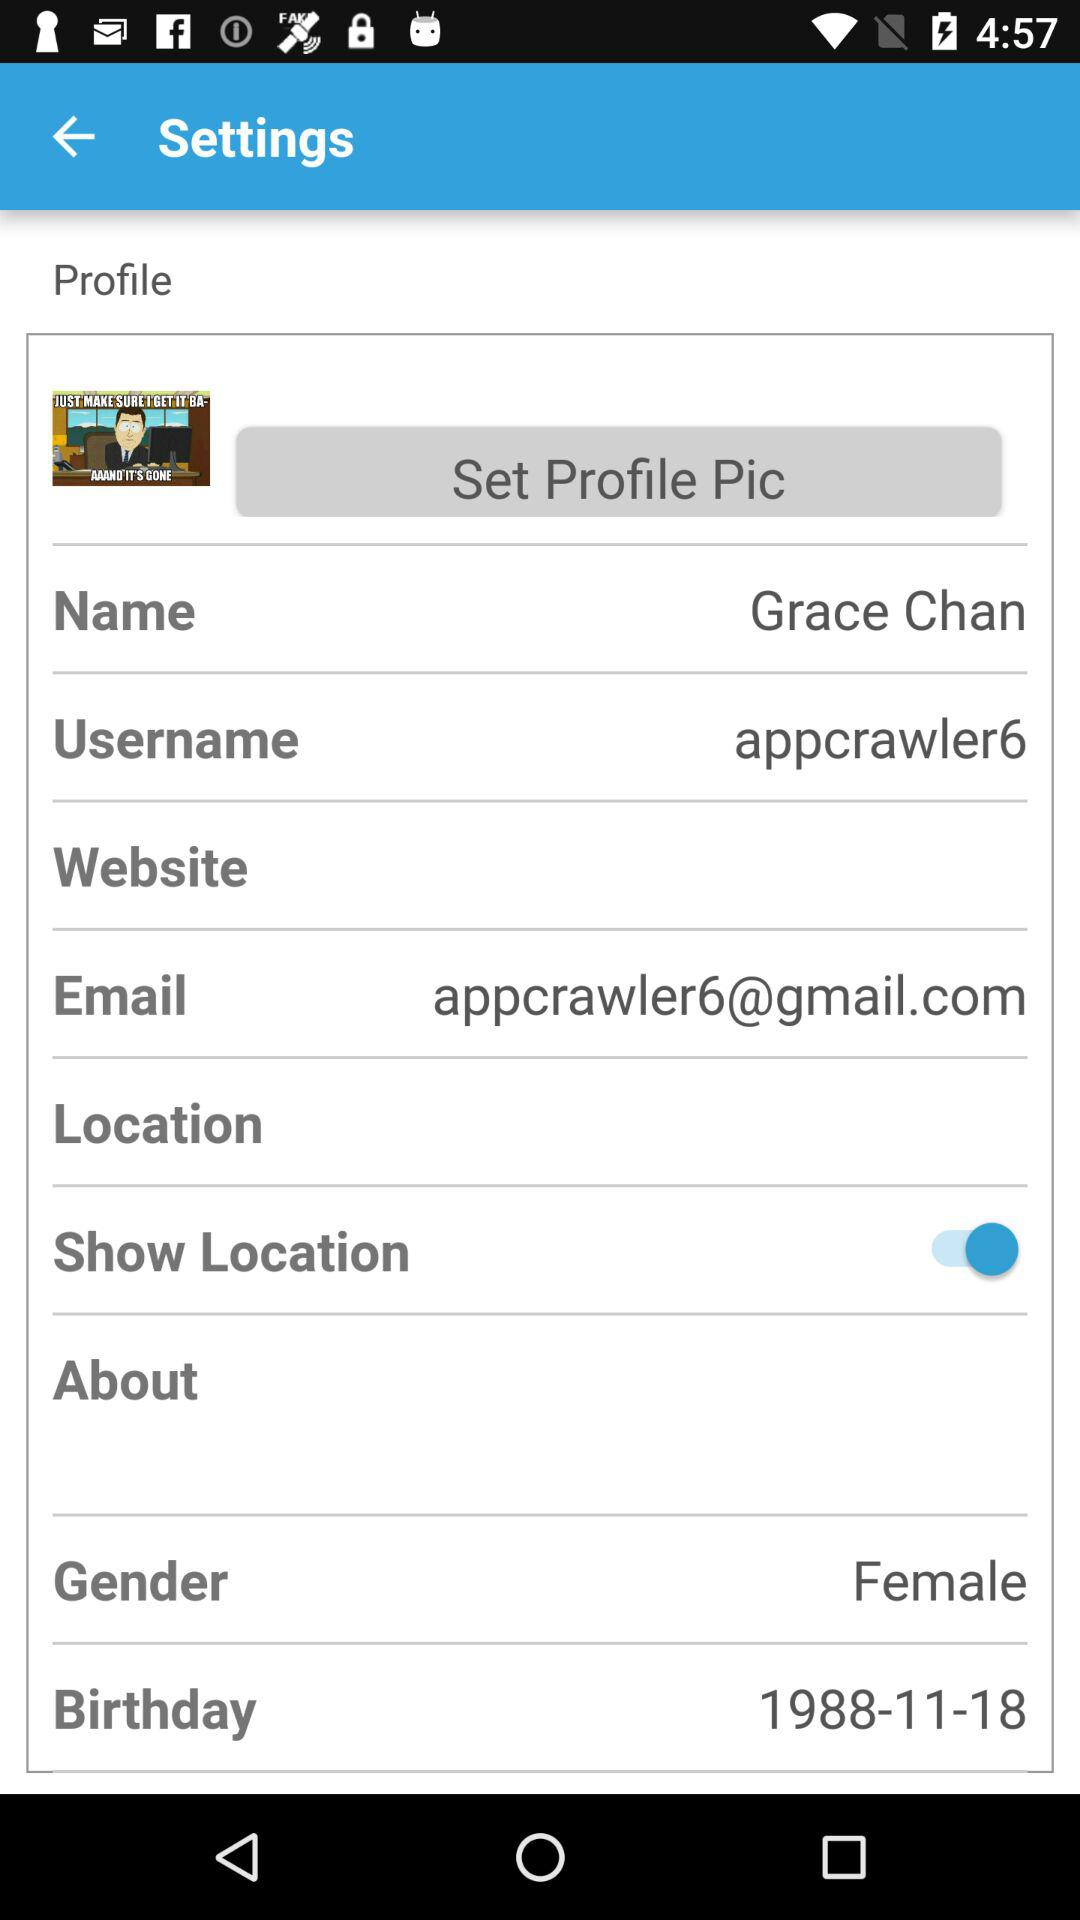What is the email address? The email address is appcrawler6@gmail.com. 